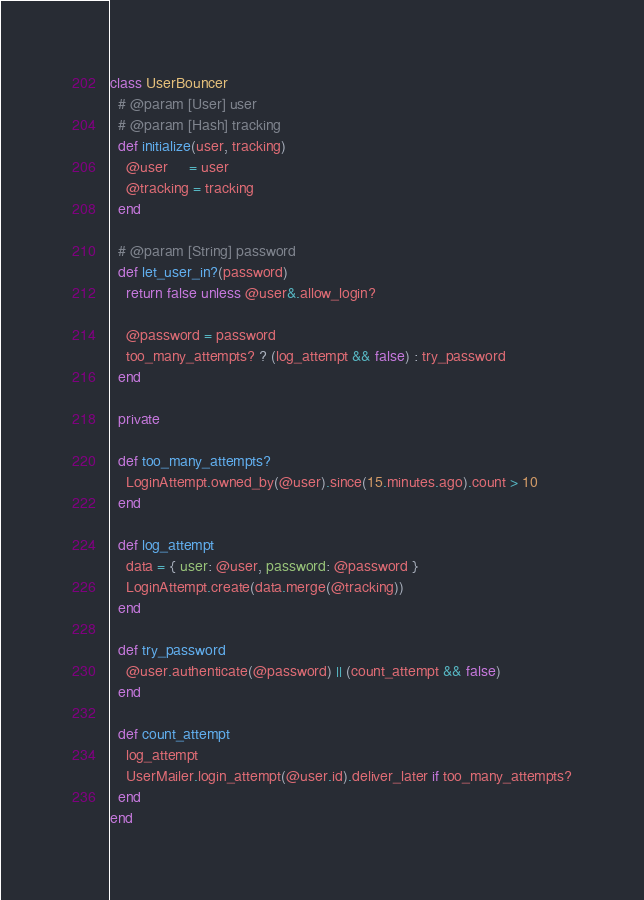<code> <loc_0><loc_0><loc_500><loc_500><_Ruby_>class UserBouncer
  # @param [User] user
  # @param [Hash] tracking
  def initialize(user, tracking)
    @user     = user
    @tracking = tracking
  end

  # @param [String] password
  def let_user_in?(password)
    return false unless @user&.allow_login?

    @password = password
    too_many_attempts? ? (log_attempt && false) : try_password
  end

  private

  def too_many_attempts?
    LoginAttempt.owned_by(@user).since(15.minutes.ago).count > 10
  end

  def log_attempt
    data = { user: @user, password: @password }
    LoginAttempt.create(data.merge(@tracking))
  end

  def try_password
    @user.authenticate(@password) || (count_attempt && false)
  end

  def count_attempt
    log_attempt
    UserMailer.login_attempt(@user.id).deliver_later if too_many_attempts?
  end
end
</code> 